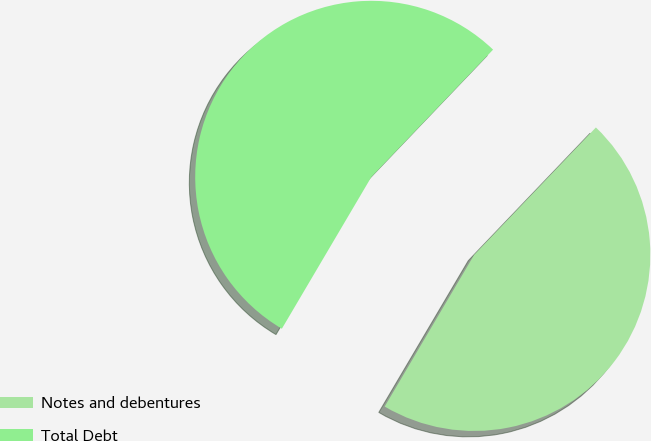Convert chart. <chart><loc_0><loc_0><loc_500><loc_500><pie_chart><fcel>Notes and debentures<fcel>Total Debt<nl><fcel>46.34%<fcel>53.66%<nl></chart> 